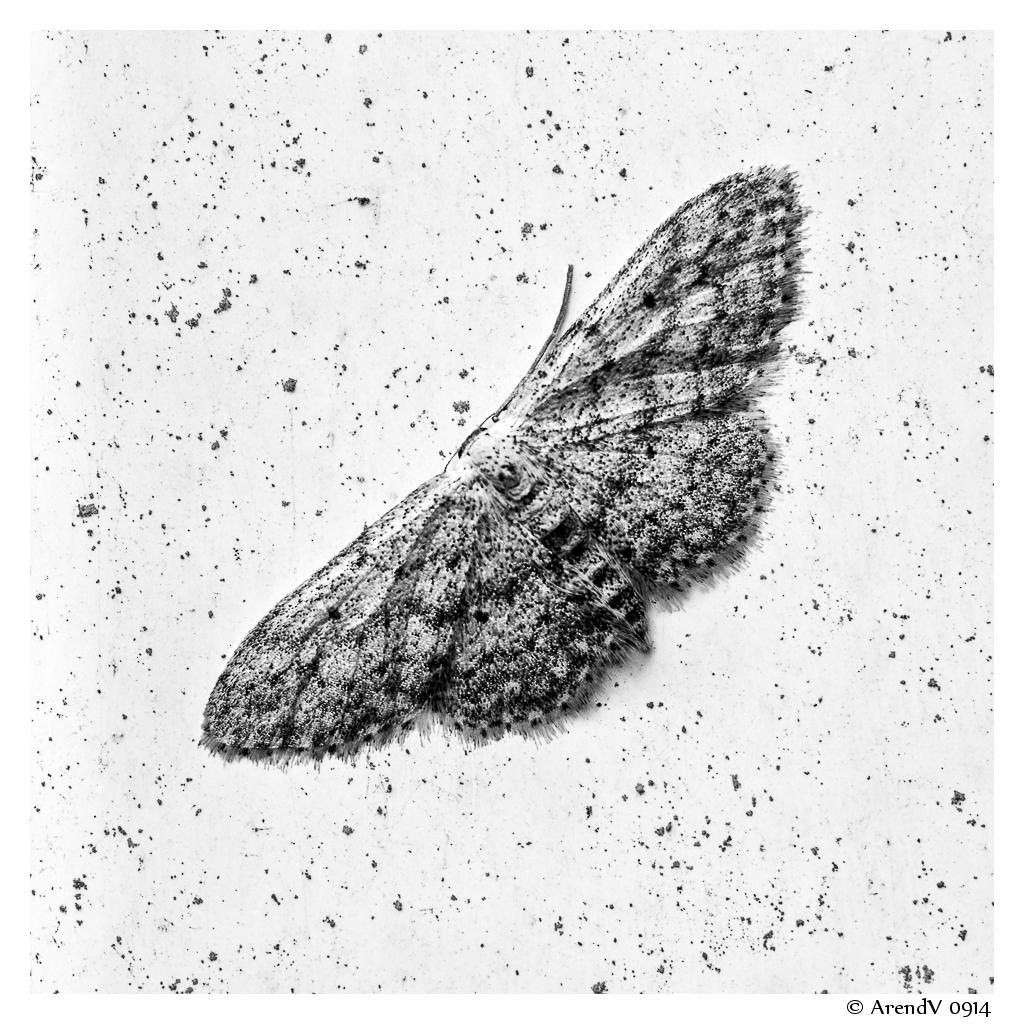What is the main subject of the image? There is a butterfly in the image. Where is the butterfly located? The butterfly is on a flat rock. What type of pen is the butterfly using to write on the rock? There is no pen present in the image, and butterflies do not write. 